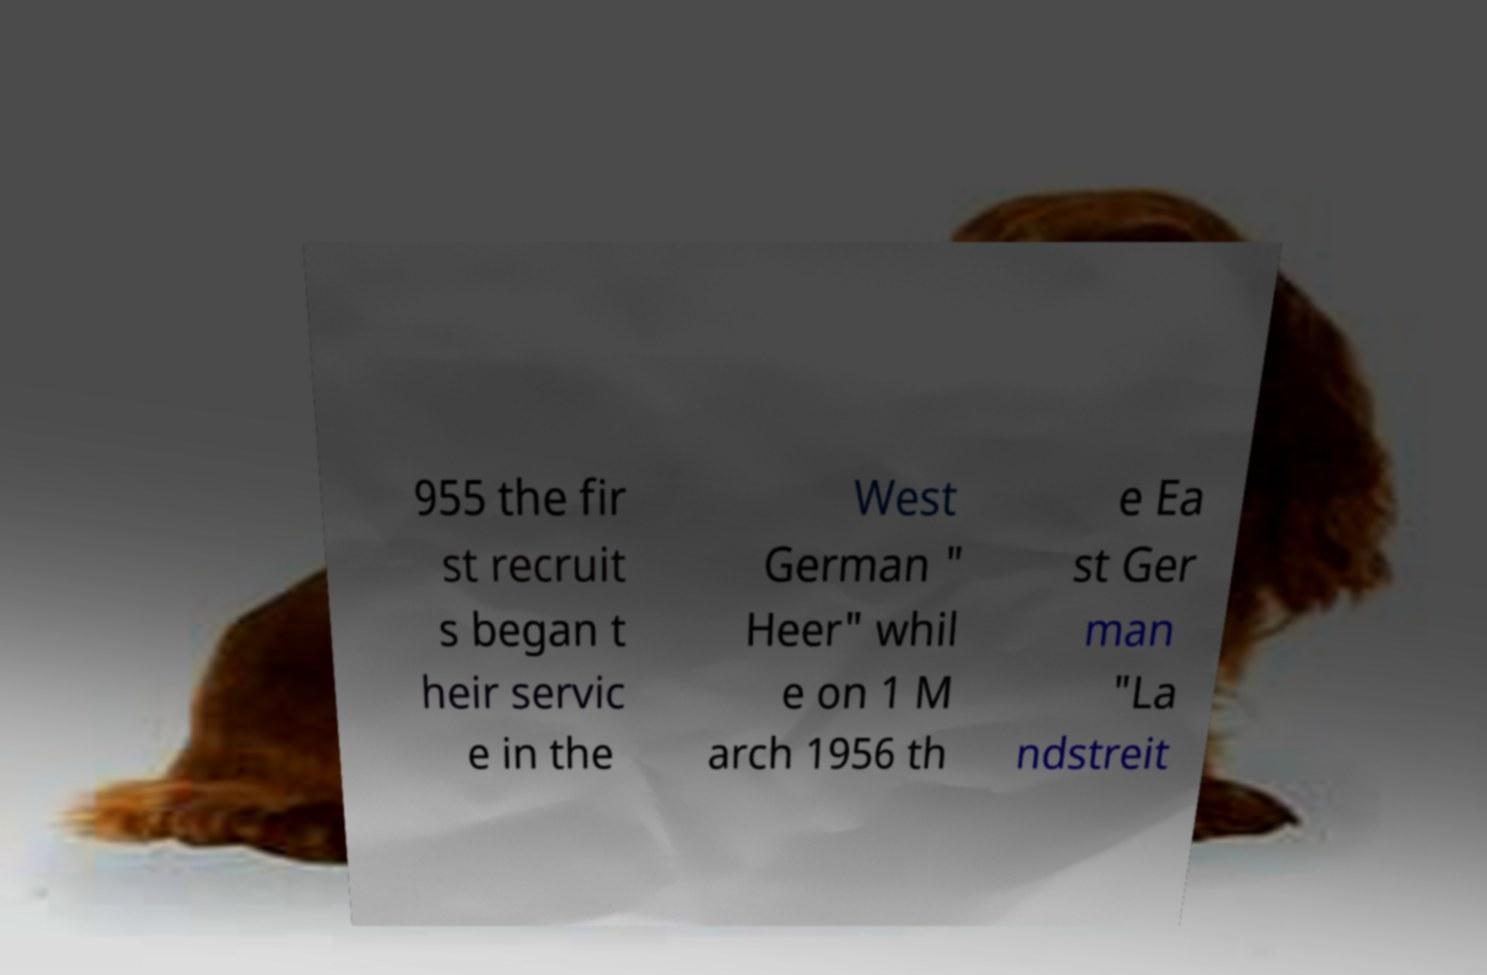Please identify and transcribe the text found in this image. 955 the fir st recruit s began t heir servic e in the West German " Heer" whil e on 1 M arch 1956 th e Ea st Ger man "La ndstreit 